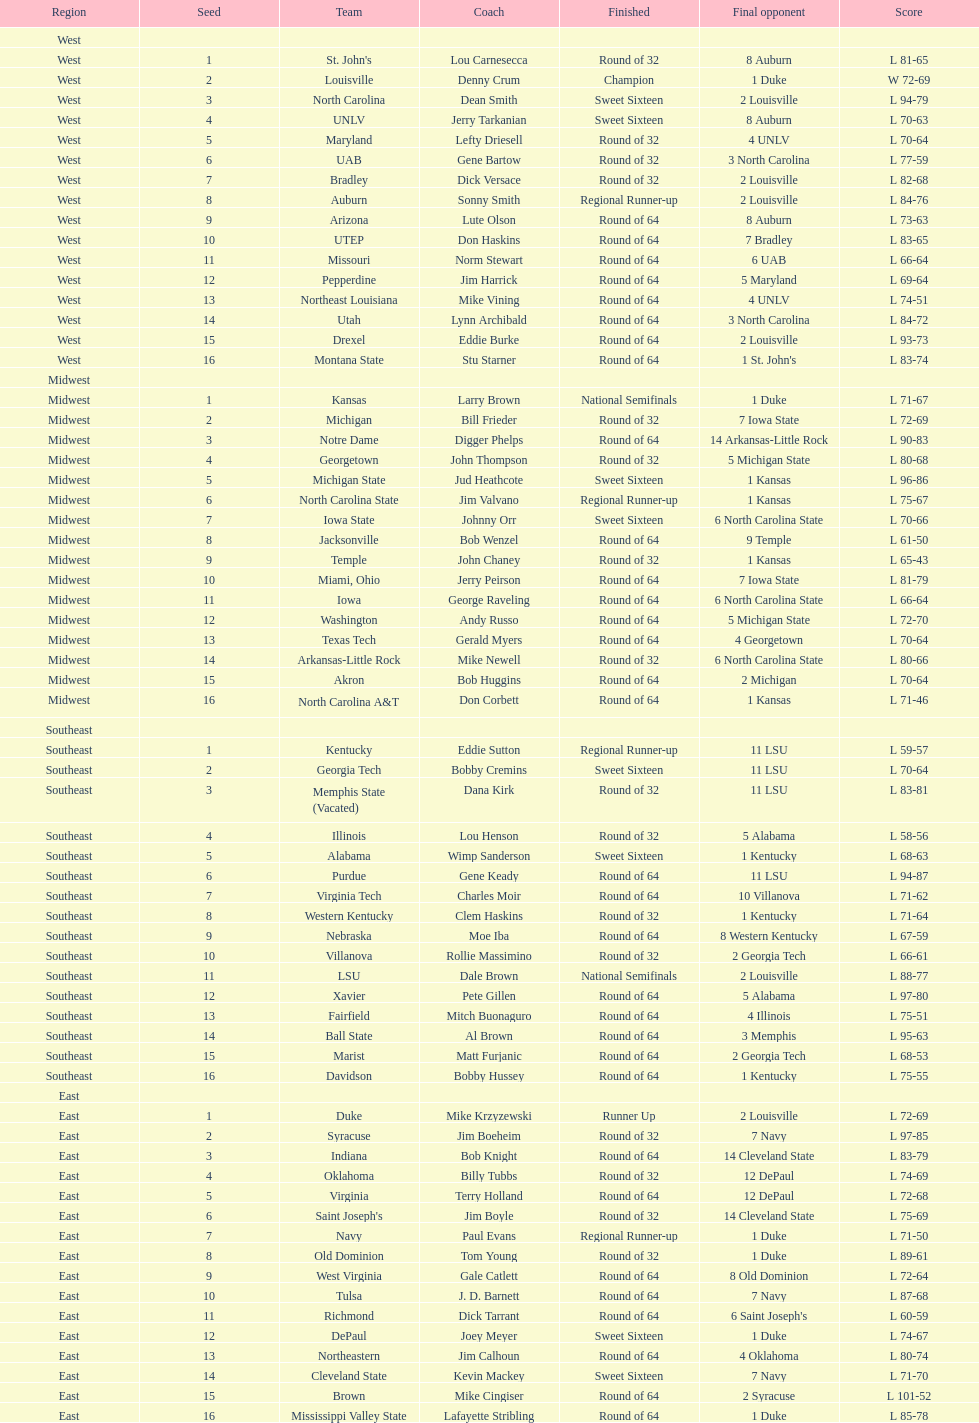What team concluded their season as champions, surpassing all other teams? Louisville. 